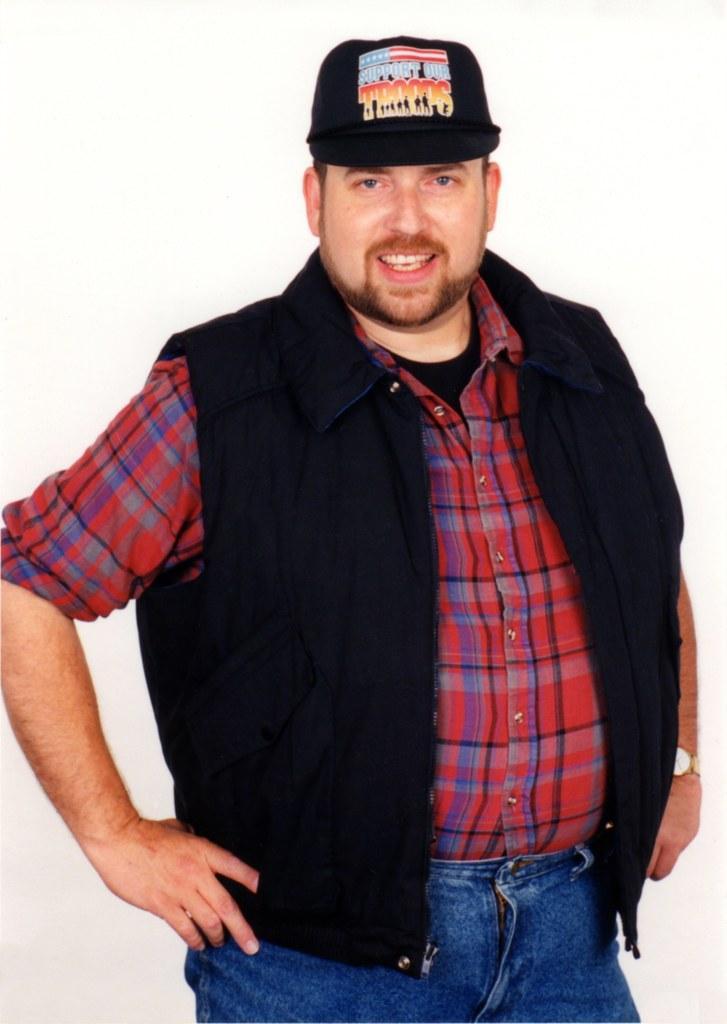In one or two sentences, can you explain what this image depicts? In the picture I can see a person wearing red color shirt, black jacket, jeans and cap is standing here and smiling and the background of the image is in white color. 